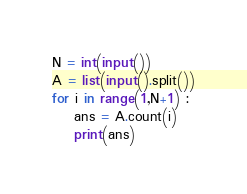Convert code to text. <code><loc_0><loc_0><loc_500><loc_500><_Python_>N = int(input())
A = list(input().split())
for i in range(1,N+1) :
    ans = A.count(i)
    print(ans)</code> 